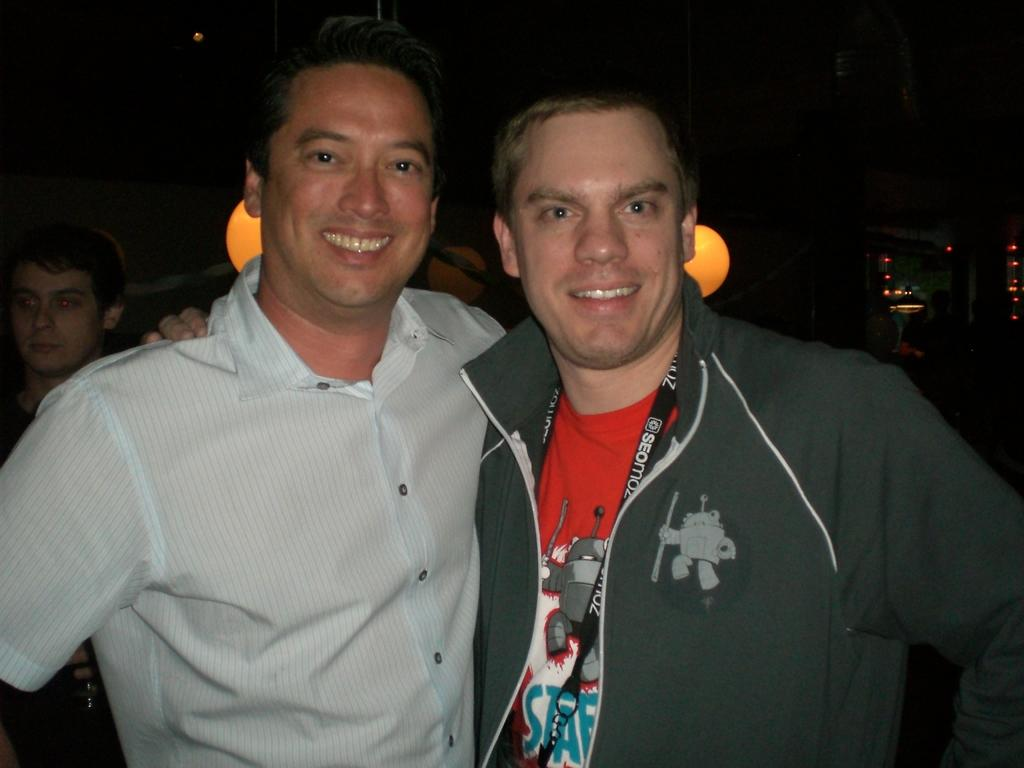How many people are present in the image? There are two persons in the image. Can you describe any distinguishing features of one of the persons? One person is wearing a tag. Are there any other people visible in the image? Yes, there is another person in the background of the image. What can be seen in the image besides the people? Lights are visible in the image. What type of circle can be seen burning in the image? There is no circle or any indication of burning in the image. 